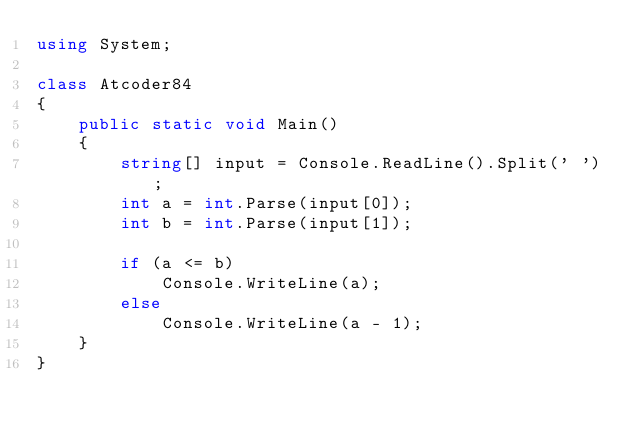Convert code to text. <code><loc_0><loc_0><loc_500><loc_500><_C#_>using System;

class Atcoder84
{
    public static void Main()
    {
        string[] input = Console.ReadLine().Split(' ');
        int a = int.Parse(input[0]);
        int b = int.Parse(input[1]);

        if (a <= b)
            Console.WriteLine(a);
        else
            Console.WriteLine(a - 1);
    }
}</code> 